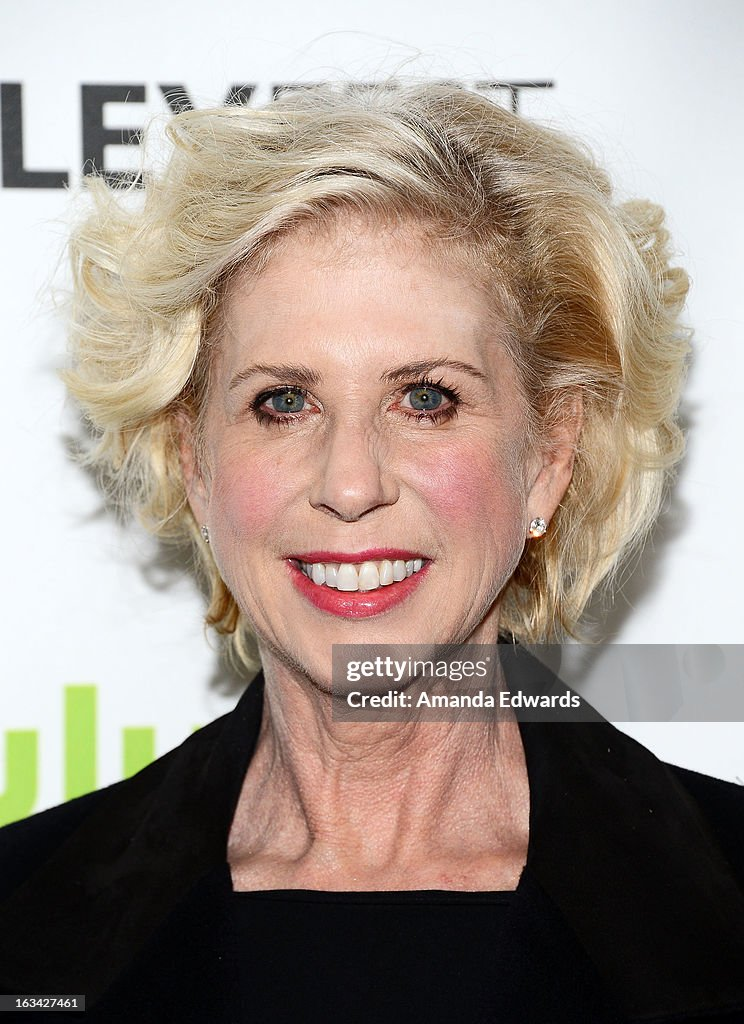What kind of attire do you think is appropriate for this event? Given the formal nature suggested by the step-and-repeat banner, attendees likely wear elegant and stylish outfits. This might include suits, evening gowns, and other cocktail attire, ensuring that individuals look their best for the cameras and make a statement on the red carpet. Could you describe the atmosphere at such an event? The atmosphere at such events is usually buzzing with excitement and glamour. Flashing cameras, media personnel, and fans eager to catch a glimpse of their favorite celebrities create a dynamic and high-energy environment. There's a sense of anticipation and celebration as attendees network, pose for photographs, and participate in interviews. Elegance and sophistication define the mood, with everyone striving to capture the spotlight and make memorable impressions. 